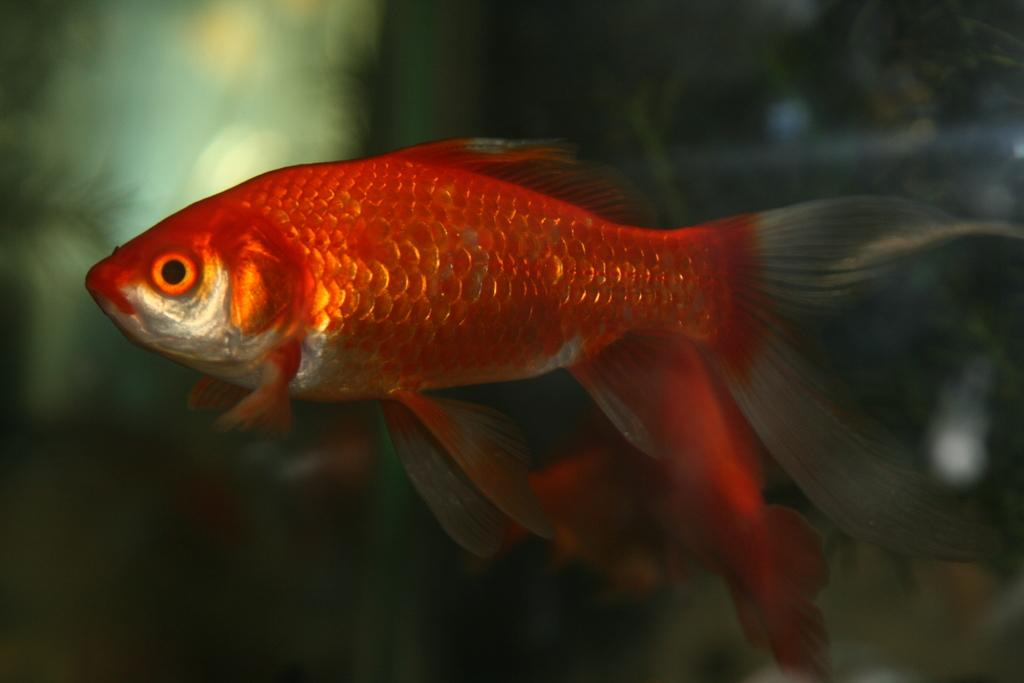What is the main subject of the image? There is a fish in the image. Can you describe the color of the fish? The fish is orange in color. What colors are present in the background of the image? The background of the image has green and orange colors. Where might this image have been taken? The image might have been taken in an aquarium. How many loaves of bread are visible in the image? There are no loaves of bread present in the image; it features a fish in an aquarium-like setting. Can you see any trucks in the image? There are no trucks visible in the image; it focuses on a fish in an aquarium-like setting. 